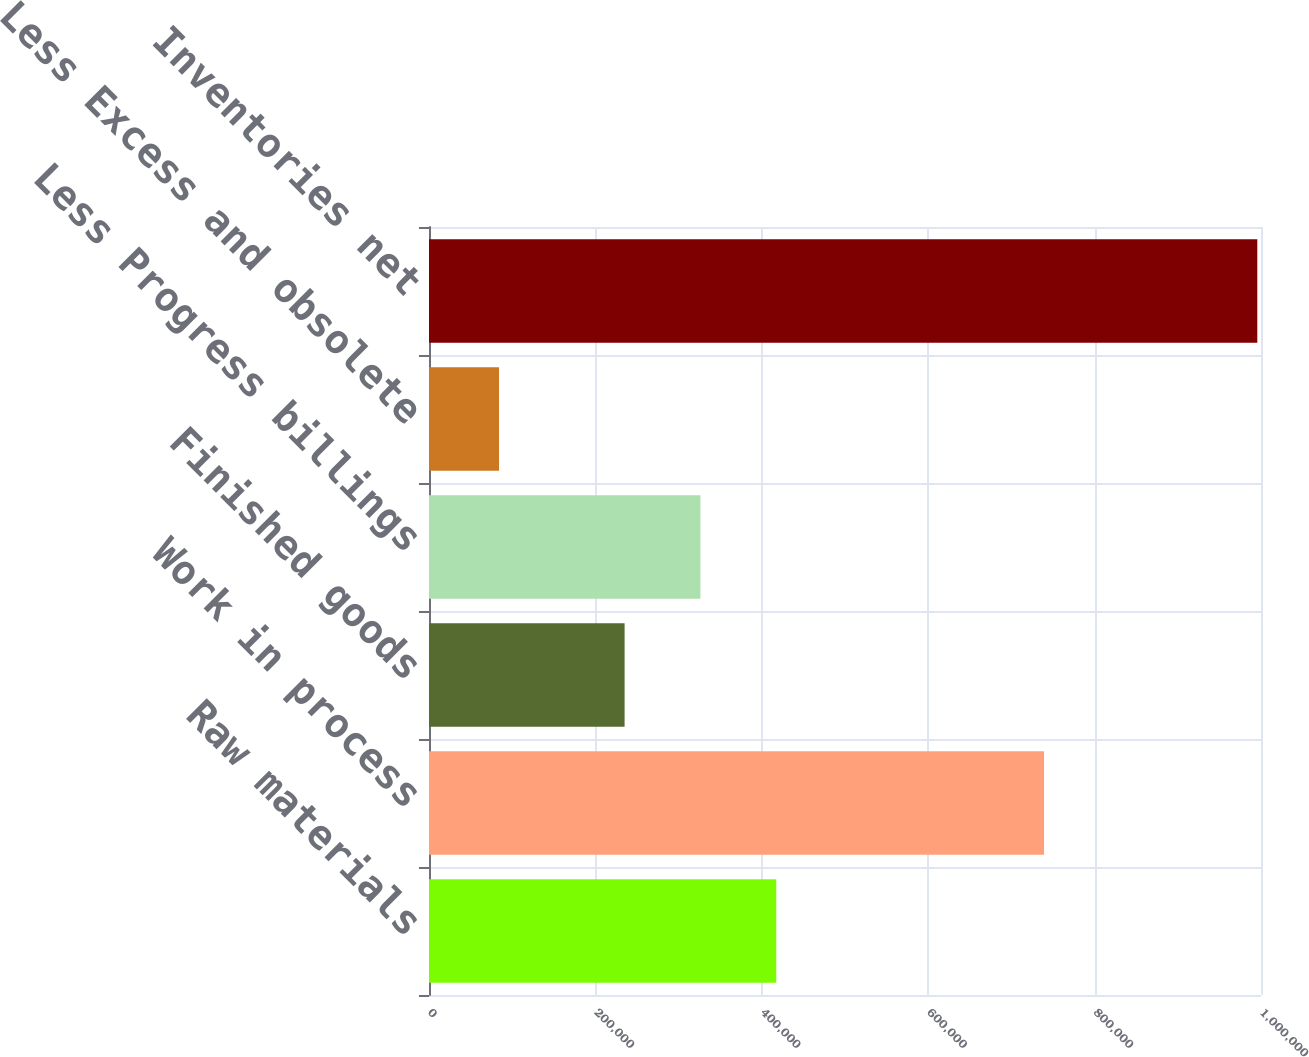<chart> <loc_0><loc_0><loc_500><loc_500><bar_chart><fcel>Raw materials<fcel>Work in process<fcel>Finished goods<fcel>Less Progress billings<fcel>Less Excess and obsolete<fcel>Inventories net<nl><fcel>417364<fcel>739227<fcel>235083<fcel>326223<fcel>84161<fcel>995565<nl></chart> 